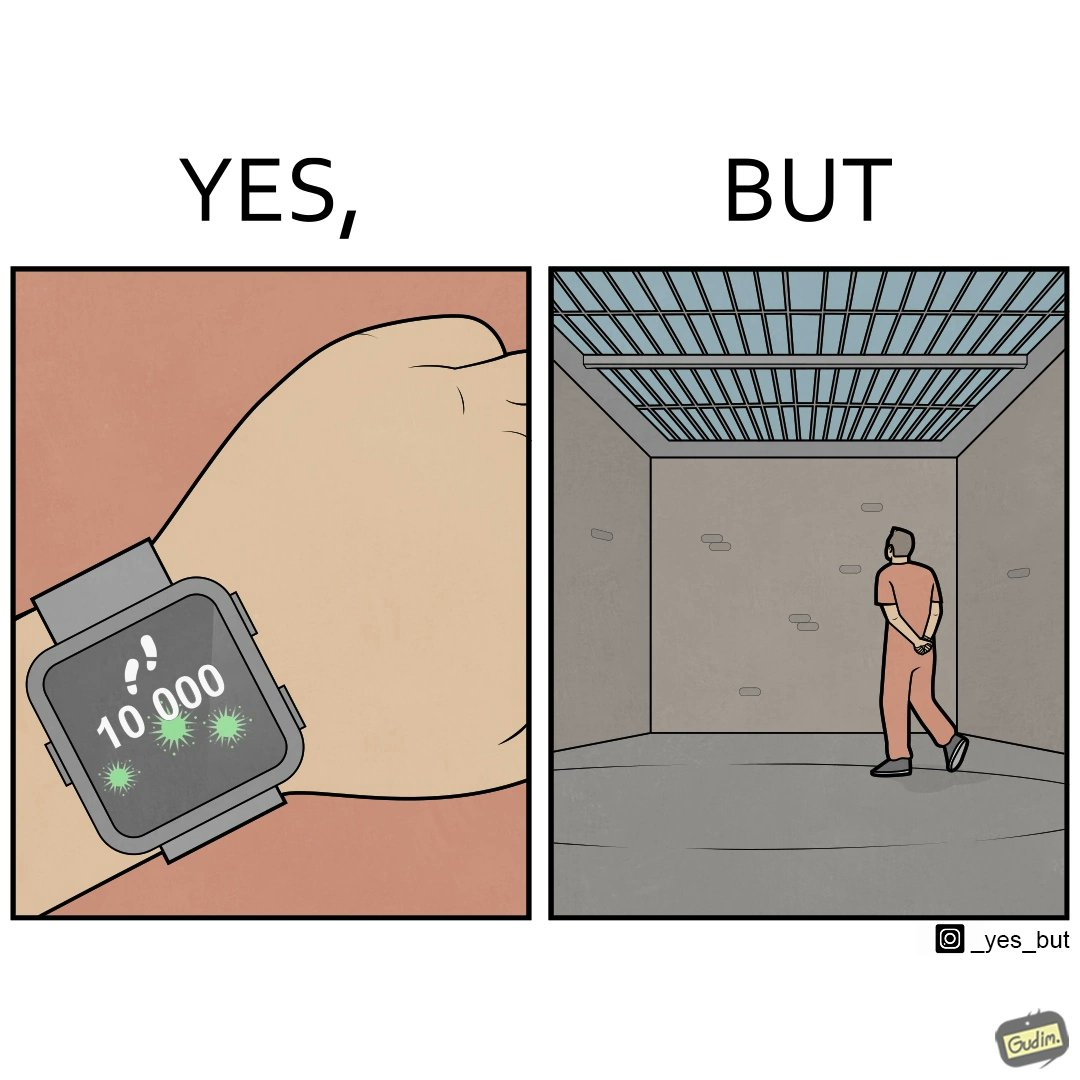What is shown in this image? The image is ironical, as the smartwatch on the person's wrist shows 10,000 steps completed as an accomplishment, while showing later that the person is apparently walking inside a jail as a prisoner. 